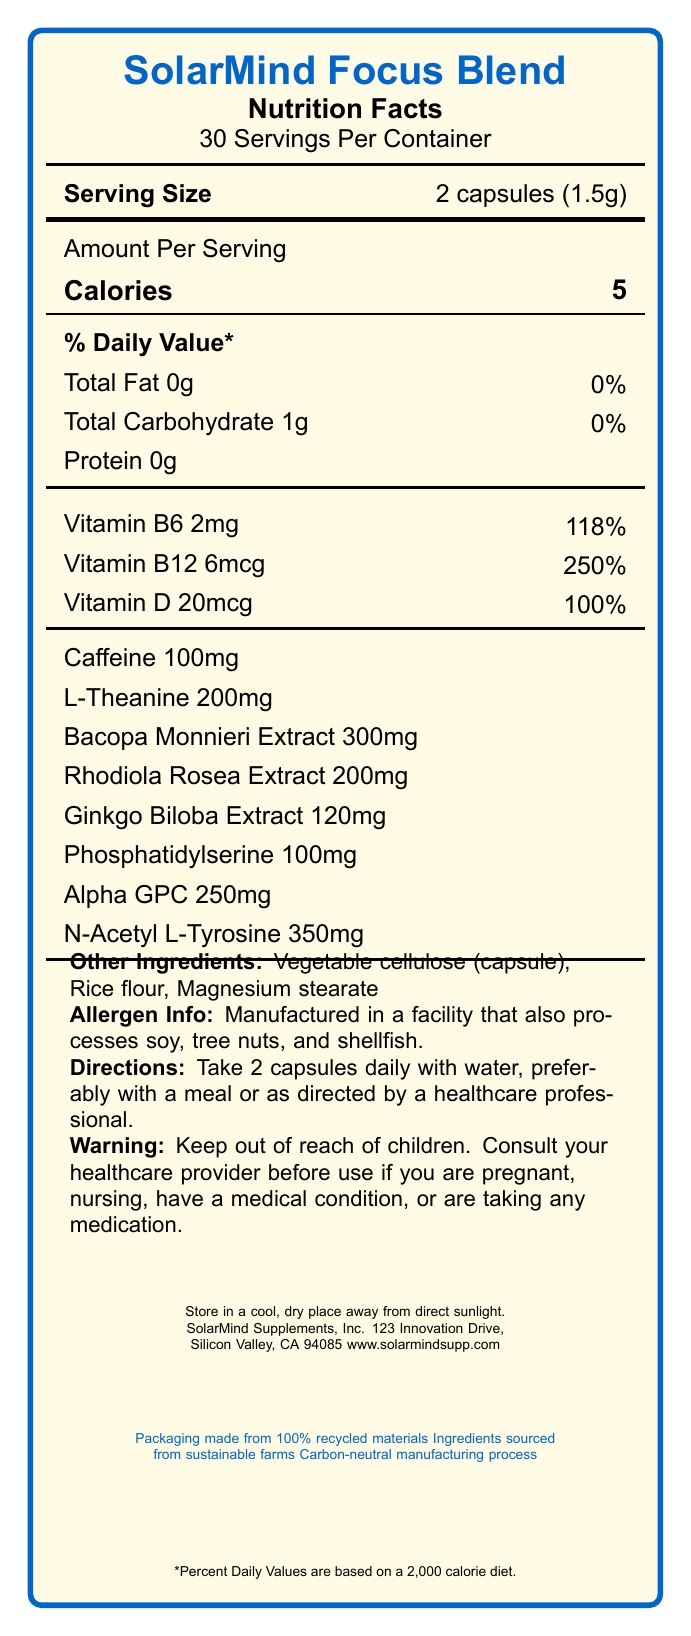what is the serving size? The serving size is listed as "2 capsules (1.5g)" in the document.
Answer: 2 capsules (1.5g) how many calories are in one serving? The number of calories per serving is shown as "5".
Answer: 5 what vitamins are included in the SolarMind Focus Blend? The document lists Vitamin B6 (2mg), Vitamin B12 (6mcg), and Vitamin D (20mcg) in the ingredients section.
Answer: Vitamin B6, Vitamin B12, Vitamin D what is the amount of caffeine per serving? The document specifies "Caffeine 100mg" as part of the amount per serving.
Answer: 100mg how many servings are in one container? The document states there are 30 servings per container.
Answer: 30 which of the following ingredients is NOT part of the SolarMind Focus Blend? A. Bacopa Monnieri Extract B. L-Theanine C. Magnesium Stearate D. Ginkgo Biloba Extract Magnesium Stearate is listed under "Other Ingredients", whereas the others are part of the main blend ingredients.
Answer: C. Magnesium Stearate how should the SolarMind Focus Blend be stored? A. In the refrigerator B. At room temperature C. In a cool, dry place D. In a dark place The document advises to "Store in a cool, dry place away from direct sunlight."
Answer: C. In a cool, dry place is this product suitable for people with soy allergies? The allergen information states "Manufactured in a facility that also processes soy, tree nuts, and shellfish."
Answer: No summarize the main idea of the document. This summarizes the key aspects of the Nutrition Facts Label, providing a broad overview including serving details, ingredients, usage instructions, and sustainability notes.
Answer: The document is a Nutrition Facts Label for SolarMind Focus Blend, a brain-boosting supplement designed to enhance focus and productivity. It lists serving size, calorie count, key vitamins and ingredients, directions for use, allergen warnings, and storage instructions. The label emphasizes the blend's cognitive benefits and highlights its sustainable packaging. is this product suitable for children? The warning specifies to "Keep out of reach of children," indicating that it is not intended for children.
Answer: No what type of capsule is used in this product? The document mentions "Vegetable cellulose" as the capsule material in the list of other ingredients.
Answer: Vegetable cellulose does this product contain any protein? The document lists "Protein 0g", which indicates it contains no protein.
Answer: No how much N-Acetyl L-Tyrosine is in each serving of the SolarMind Focus Blend? The document states that each serving contains "N-Acetyl L-Tyrosine 350mg".
Answer: 350mg which ingredient in the SolarMind Focus Blend has the highest amount per serving? Bacopa Monnieri Extract has the highest amount per serving at 300mg, compared to the other listed ingredients.
Answer: Bacopa Monnieri Extract what is the source of the recycled packaging material? The document mentions that the packaging is made from 100% recycled materials, but does not specify the source of these materials.
Answer: Cannot be determined 